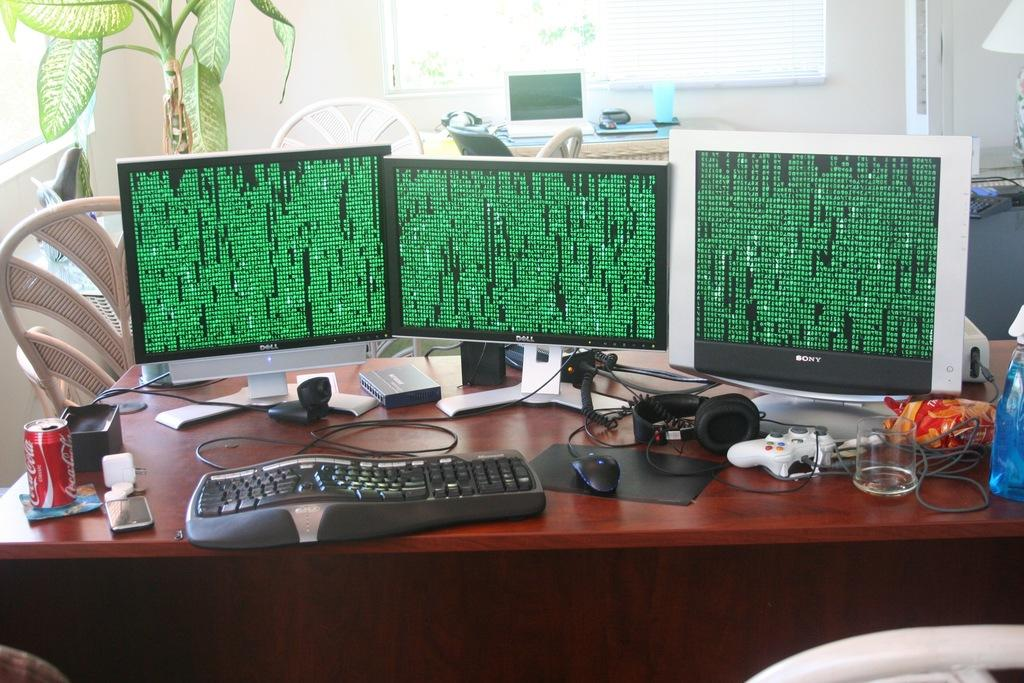What is the main object in the center of the image? There is a table in the center of the image. What electronic devices are on the table? Monitors, keyboards, and mice are on the table. What type of beverage container is on the table? There is a glass on the table. What can be seen in the background of the image? There is a wall, a plant, and empty chairs in the background of the image. Can you see a worm crawling on the table in the image? No, there is no worm present on the table in the image. What attraction is visible in the background of the image? There is no attraction visible in the image; it only shows a table, electronic devices, a glass, a wall, a plant, and empty chairs. 